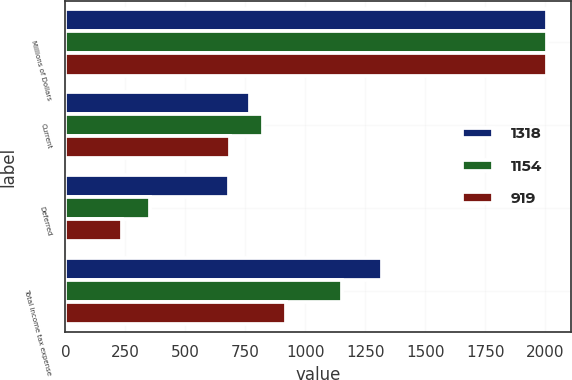<chart> <loc_0><loc_0><loc_500><loc_500><stacked_bar_chart><ecel><fcel>Millions of Dollars<fcel>Current<fcel>Deferred<fcel>Total income tax expense<nl><fcel>1318<fcel>2008<fcel>771<fcel>681<fcel>1318<nl><fcel>1154<fcel>2007<fcel>822<fcel>354<fcel>1154<nl><fcel>919<fcel>2006<fcel>684<fcel>235<fcel>919<nl></chart> 